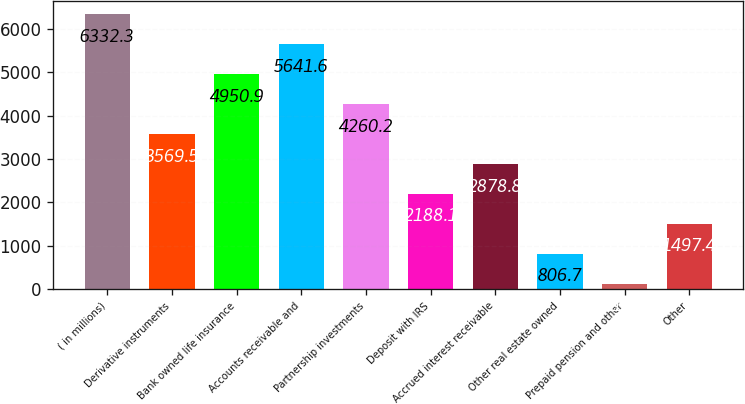Convert chart. <chart><loc_0><loc_0><loc_500><loc_500><bar_chart><fcel>( in millions)<fcel>Derivative instruments<fcel>Bank owned life insurance<fcel>Accounts receivable and<fcel>Partnership investments<fcel>Deposit with IRS<fcel>Accrued interest receivable<fcel>Other real estate owned<fcel>Prepaid pension and other<fcel>Other<nl><fcel>6332.3<fcel>3569.5<fcel>4950.9<fcel>5641.6<fcel>4260.2<fcel>2188.1<fcel>2878.8<fcel>806.7<fcel>116<fcel>1497.4<nl></chart> 